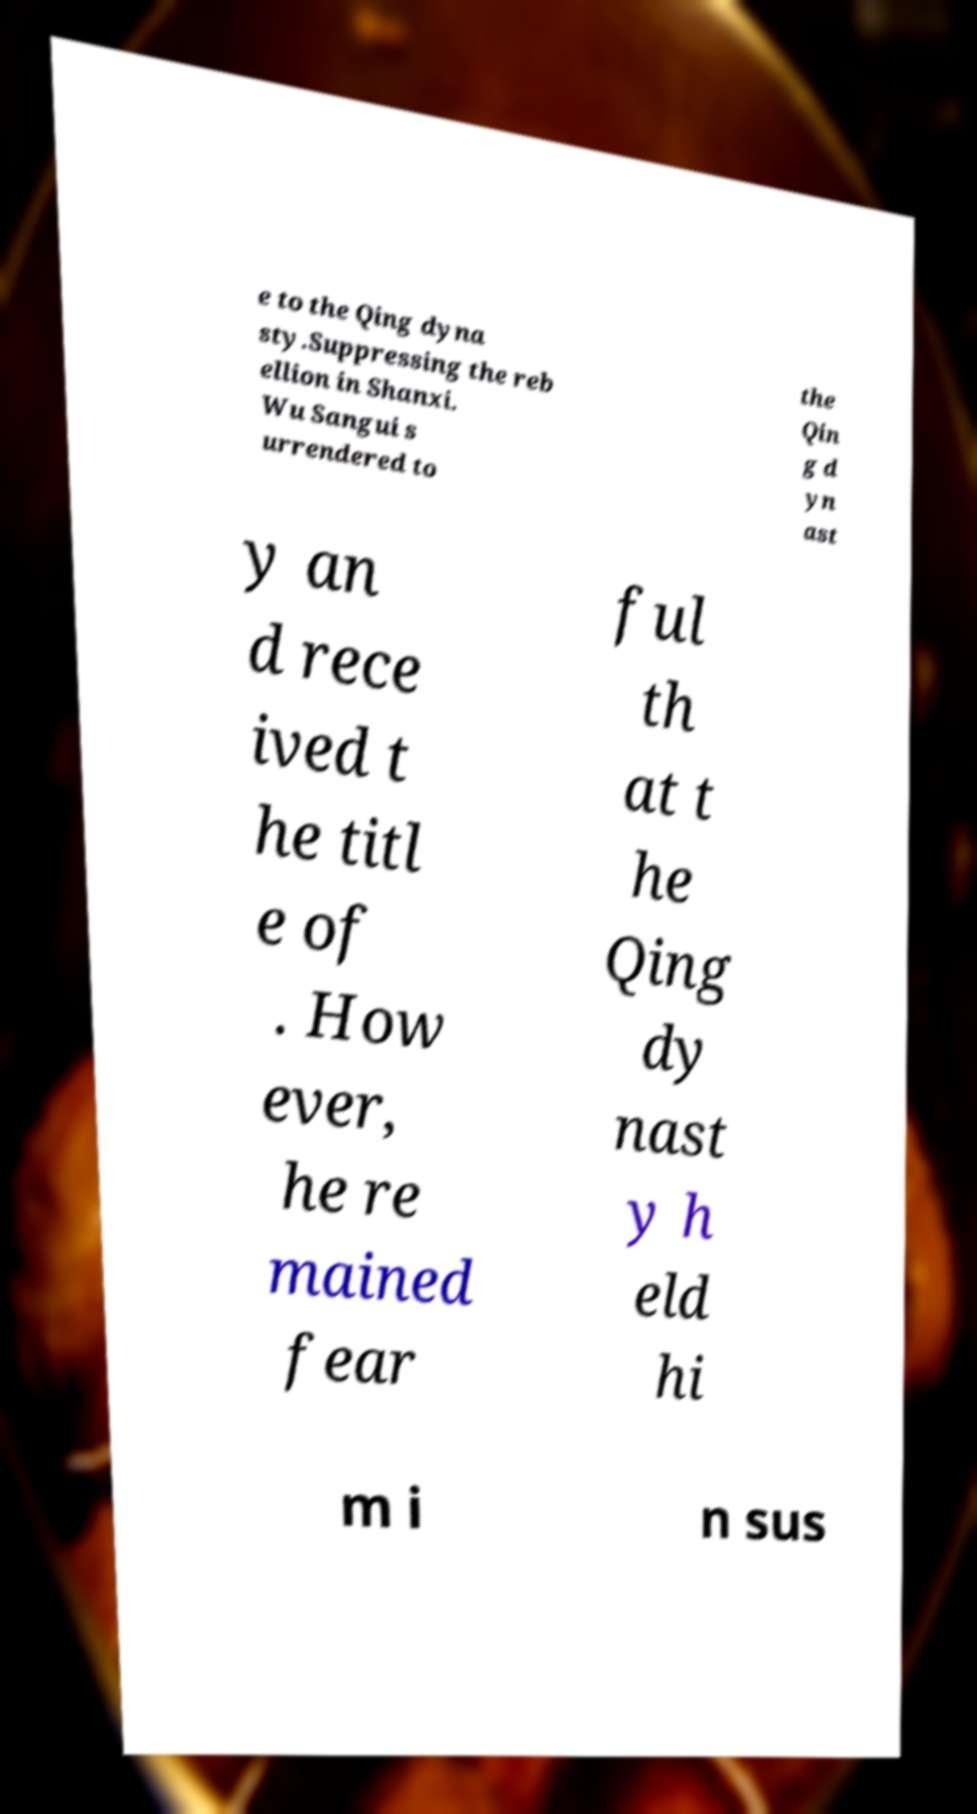I need the written content from this picture converted into text. Can you do that? e to the Qing dyna sty.Suppressing the reb ellion in Shanxi. Wu Sangui s urrendered to the Qin g d yn ast y an d rece ived t he titl e of . How ever, he re mained fear ful th at t he Qing dy nast y h eld hi m i n sus 